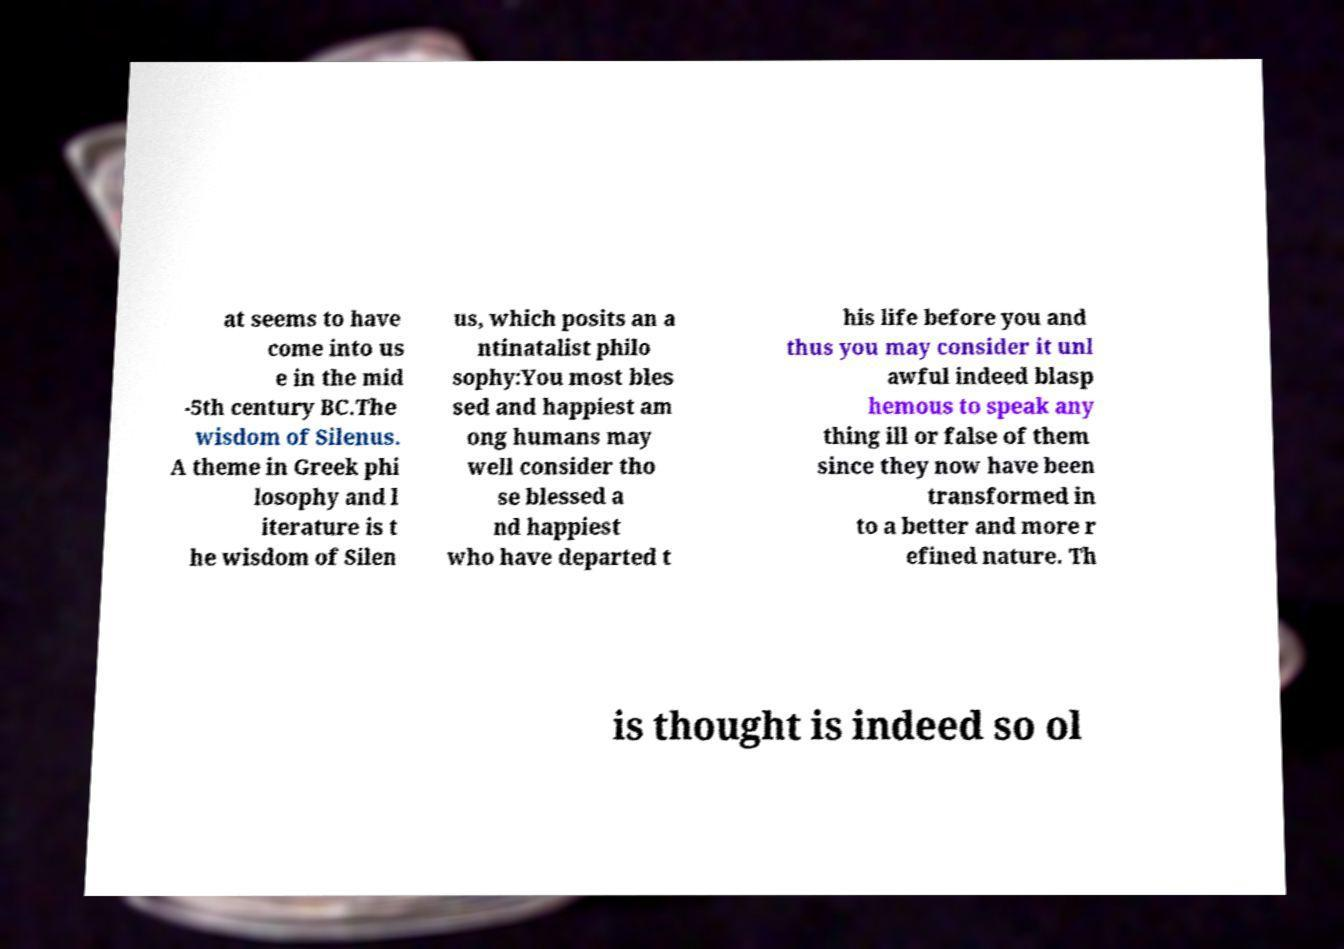Could you extract and type out the text from this image? at seems to have come into us e in the mid -5th century BC.The wisdom of Silenus. A theme in Greek phi losophy and l iterature is t he wisdom of Silen us, which posits an a ntinatalist philo sophy:You most bles sed and happiest am ong humans may well consider tho se blessed a nd happiest who have departed t his life before you and thus you may consider it unl awful indeed blasp hemous to speak any thing ill or false of them since they now have been transformed in to a better and more r efined nature. Th is thought is indeed so ol 